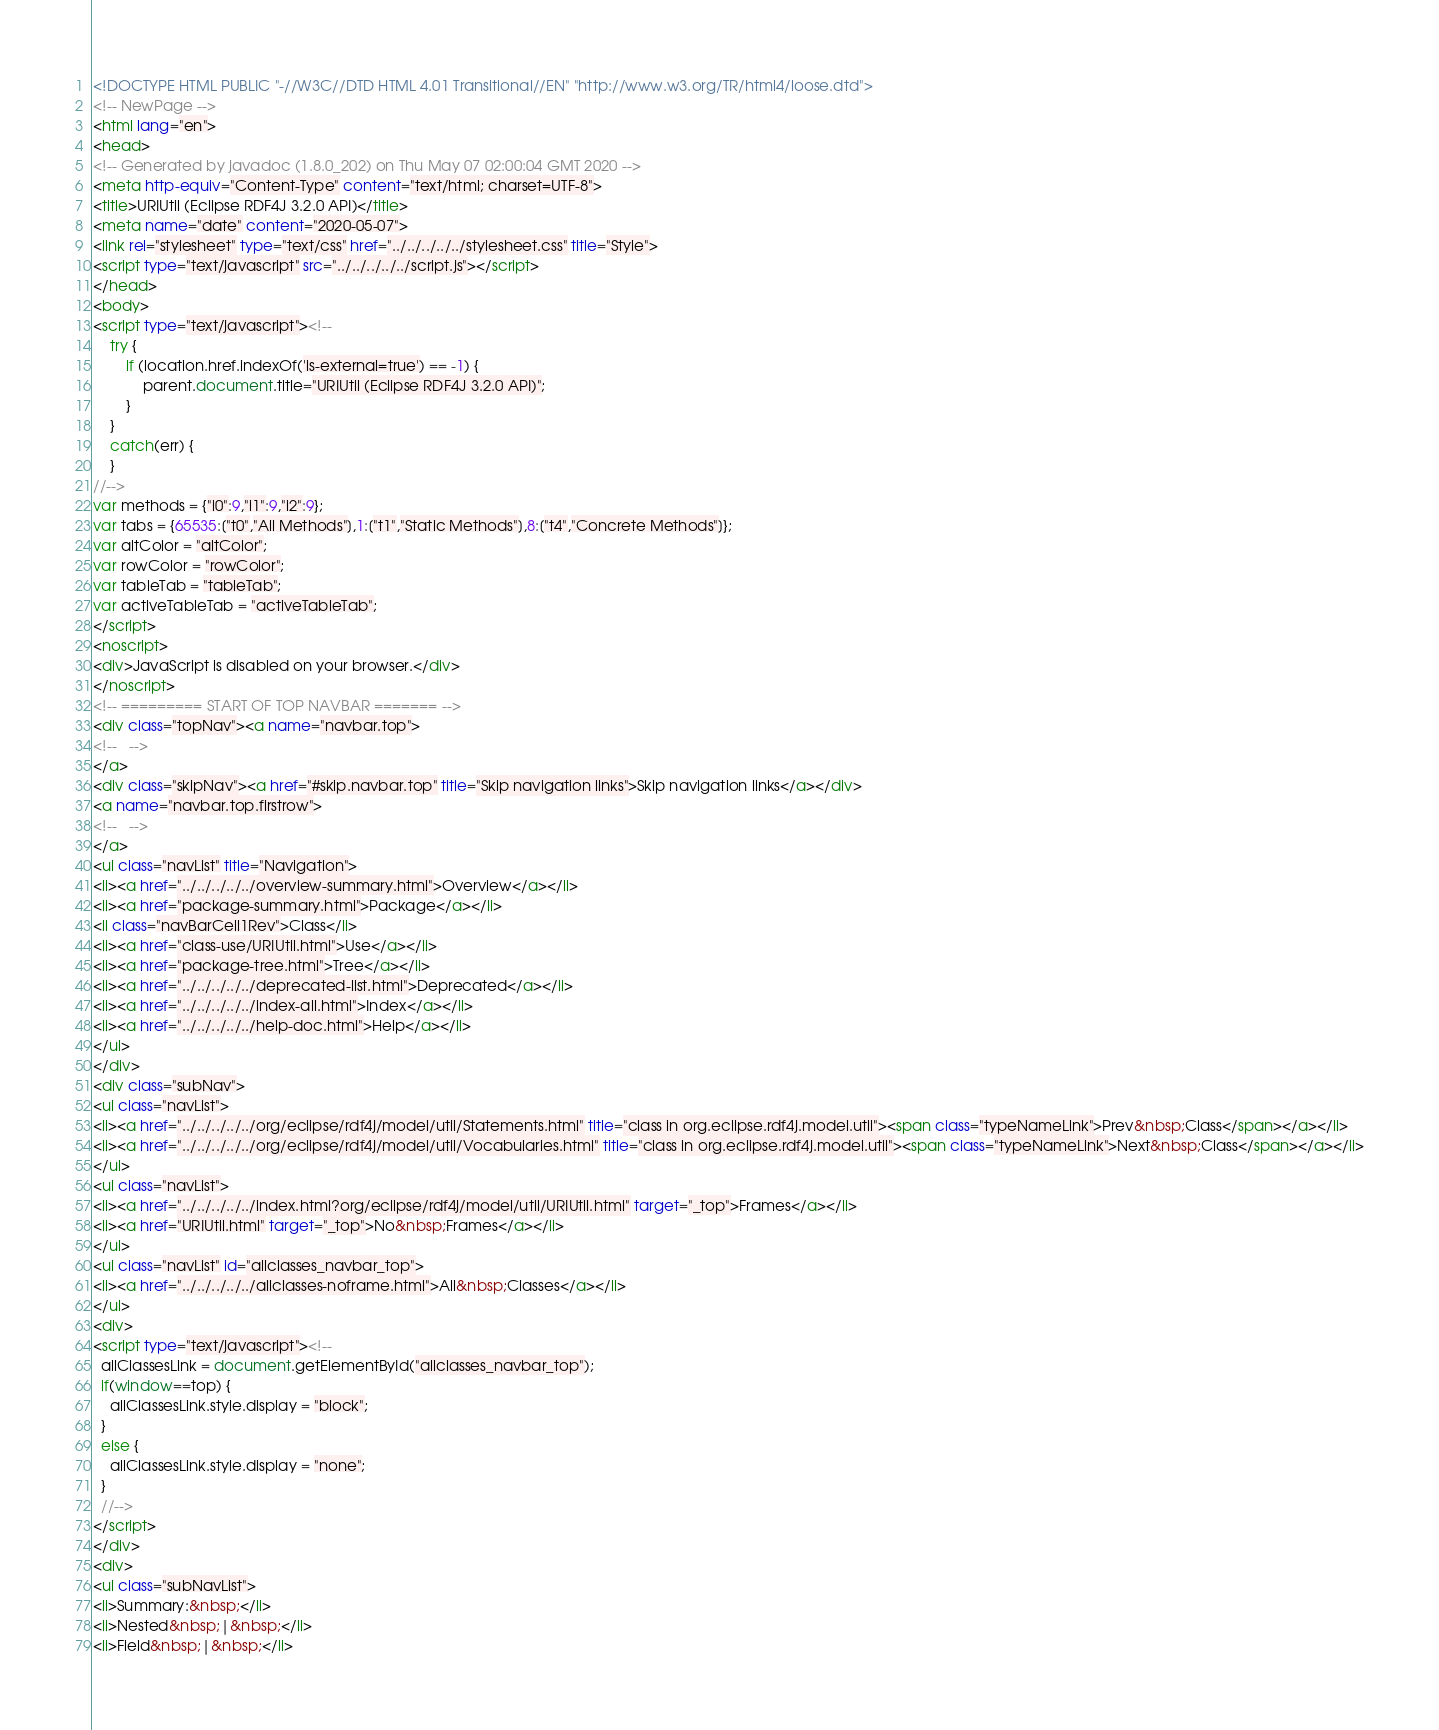Convert code to text. <code><loc_0><loc_0><loc_500><loc_500><_HTML_><!DOCTYPE HTML PUBLIC "-//W3C//DTD HTML 4.01 Transitional//EN" "http://www.w3.org/TR/html4/loose.dtd">
<!-- NewPage -->
<html lang="en">
<head>
<!-- Generated by javadoc (1.8.0_202) on Thu May 07 02:00:04 GMT 2020 -->
<meta http-equiv="Content-Type" content="text/html; charset=UTF-8">
<title>URIUtil (Eclipse RDF4J 3.2.0 API)</title>
<meta name="date" content="2020-05-07">
<link rel="stylesheet" type="text/css" href="../../../../../stylesheet.css" title="Style">
<script type="text/javascript" src="../../../../../script.js"></script>
</head>
<body>
<script type="text/javascript"><!--
    try {
        if (location.href.indexOf('is-external=true') == -1) {
            parent.document.title="URIUtil (Eclipse RDF4J 3.2.0 API)";
        }
    }
    catch(err) {
    }
//-->
var methods = {"i0":9,"i1":9,"i2":9};
var tabs = {65535:["t0","All Methods"],1:["t1","Static Methods"],8:["t4","Concrete Methods"]};
var altColor = "altColor";
var rowColor = "rowColor";
var tableTab = "tableTab";
var activeTableTab = "activeTableTab";
</script>
<noscript>
<div>JavaScript is disabled on your browser.</div>
</noscript>
<!-- ========= START OF TOP NAVBAR ======= -->
<div class="topNav"><a name="navbar.top">
<!--   -->
</a>
<div class="skipNav"><a href="#skip.navbar.top" title="Skip navigation links">Skip navigation links</a></div>
<a name="navbar.top.firstrow">
<!--   -->
</a>
<ul class="navList" title="Navigation">
<li><a href="../../../../../overview-summary.html">Overview</a></li>
<li><a href="package-summary.html">Package</a></li>
<li class="navBarCell1Rev">Class</li>
<li><a href="class-use/URIUtil.html">Use</a></li>
<li><a href="package-tree.html">Tree</a></li>
<li><a href="../../../../../deprecated-list.html">Deprecated</a></li>
<li><a href="../../../../../index-all.html">Index</a></li>
<li><a href="../../../../../help-doc.html">Help</a></li>
</ul>
</div>
<div class="subNav">
<ul class="navList">
<li><a href="../../../../../org/eclipse/rdf4j/model/util/Statements.html" title="class in org.eclipse.rdf4j.model.util"><span class="typeNameLink">Prev&nbsp;Class</span></a></li>
<li><a href="../../../../../org/eclipse/rdf4j/model/util/Vocabularies.html" title="class in org.eclipse.rdf4j.model.util"><span class="typeNameLink">Next&nbsp;Class</span></a></li>
</ul>
<ul class="navList">
<li><a href="../../../../../index.html?org/eclipse/rdf4j/model/util/URIUtil.html" target="_top">Frames</a></li>
<li><a href="URIUtil.html" target="_top">No&nbsp;Frames</a></li>
</ul>
<ul class="navList" id="allclasses_navbar_top">
<li><a href="../../../../../allclasses-noframe.html">All&nbsp;Classes</a></li>
</ul>
<div>
<script type="text/javascript"><!--
  allClassesLink = document.getElementById("allclasses_navbar_top");
  if(window==top) {
    allClassesLink.style.display = "block";
  }
  else {
    allClassesLink.style.display = "none";
  }
  //-->
</script>
</div>
<div>
<ul class="subNavList">
<li>Summary:&nbsp;</li>
<li>Nested&nbsp;|&nbsp;</li>
<li>Field&nbsp;|&nbsp;</li></code> 